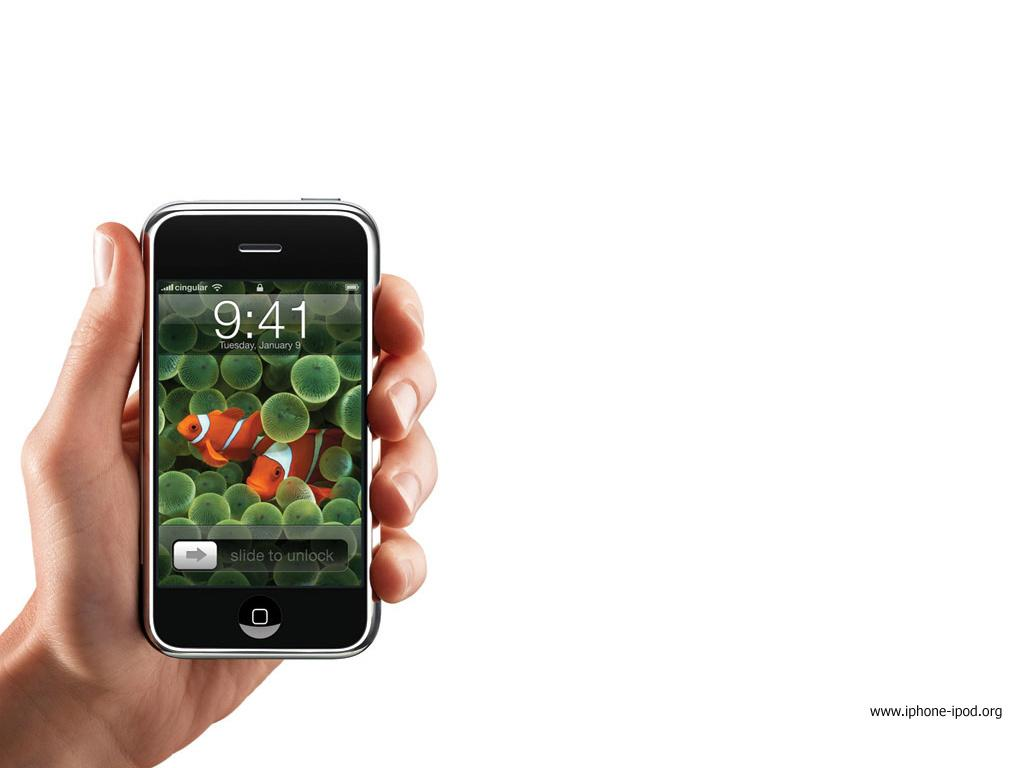What is being held by the hand in the image? There is a hand holding a mobile on the left side of the image. Where is the text located in the image? The text is at the bottom right corner of the image. What type of structure can be seen in the background of the image? There is no structure visible in the background of the image. Is there a cobweb present in the image? There is no cobweb present in the image. 